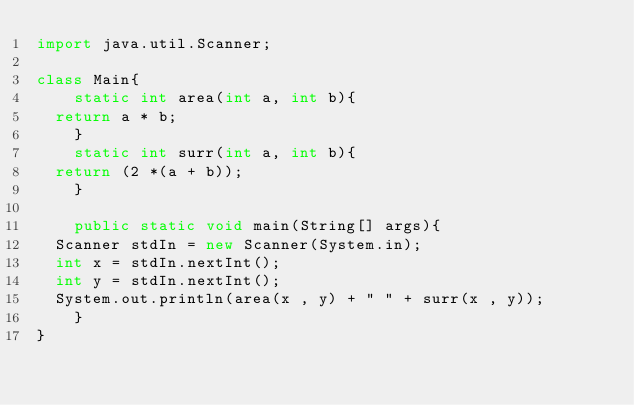Convert code to text. <code><loc_0><loc_0><loc_500><loc_500><_Java_>import java.util.Scanner;

class Main{
    static int area(int a, int b){
	return a * b;
    }
    static int surr(int a, int b){
	return (2 *(a + b));
    }

    public static void main(String[] args){
	Scanner stdIn = new Scanner(System.in);
	int x = stdIn.nextInt();
	int y = stdIn.nextInt();
	System.out.println(area(x , y) + " " + surr(x , y));
    }
}</code> 